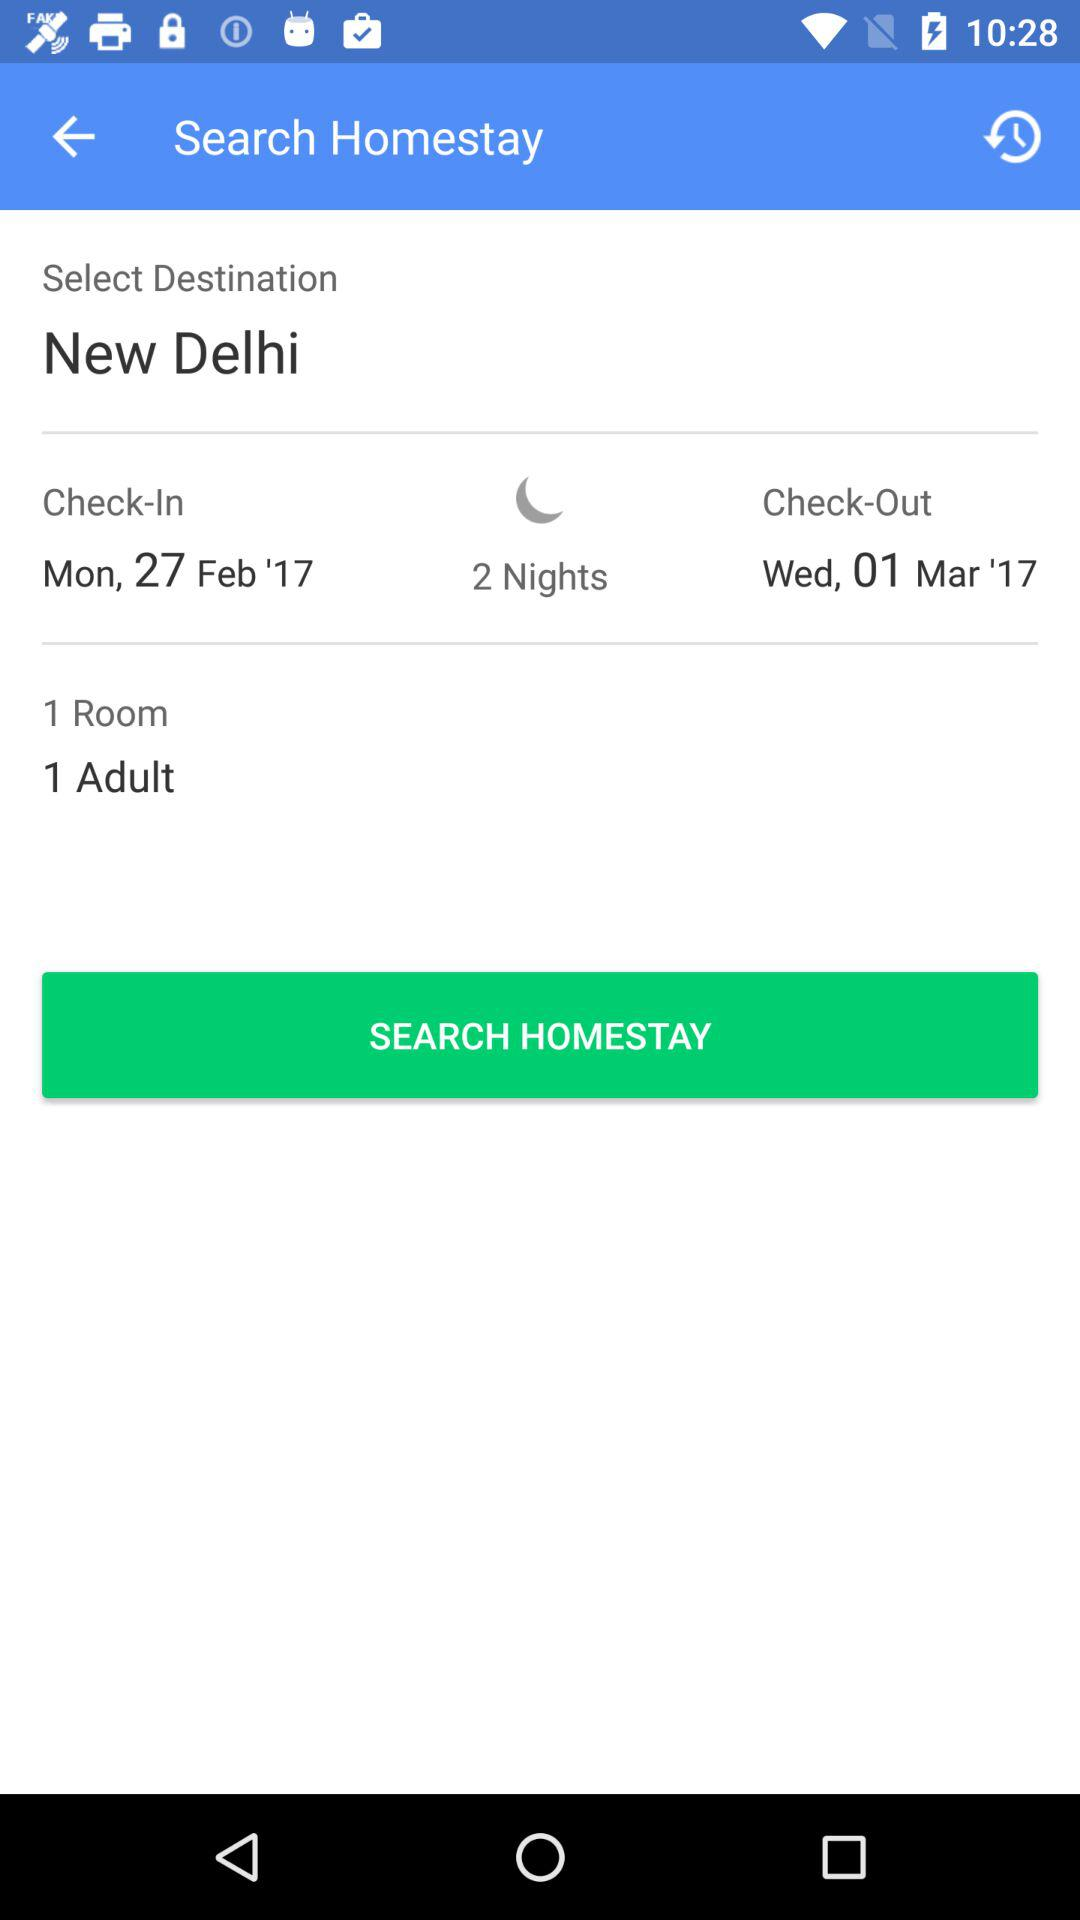How many nights are selected to stay? There are 2 nights selected to stay. 